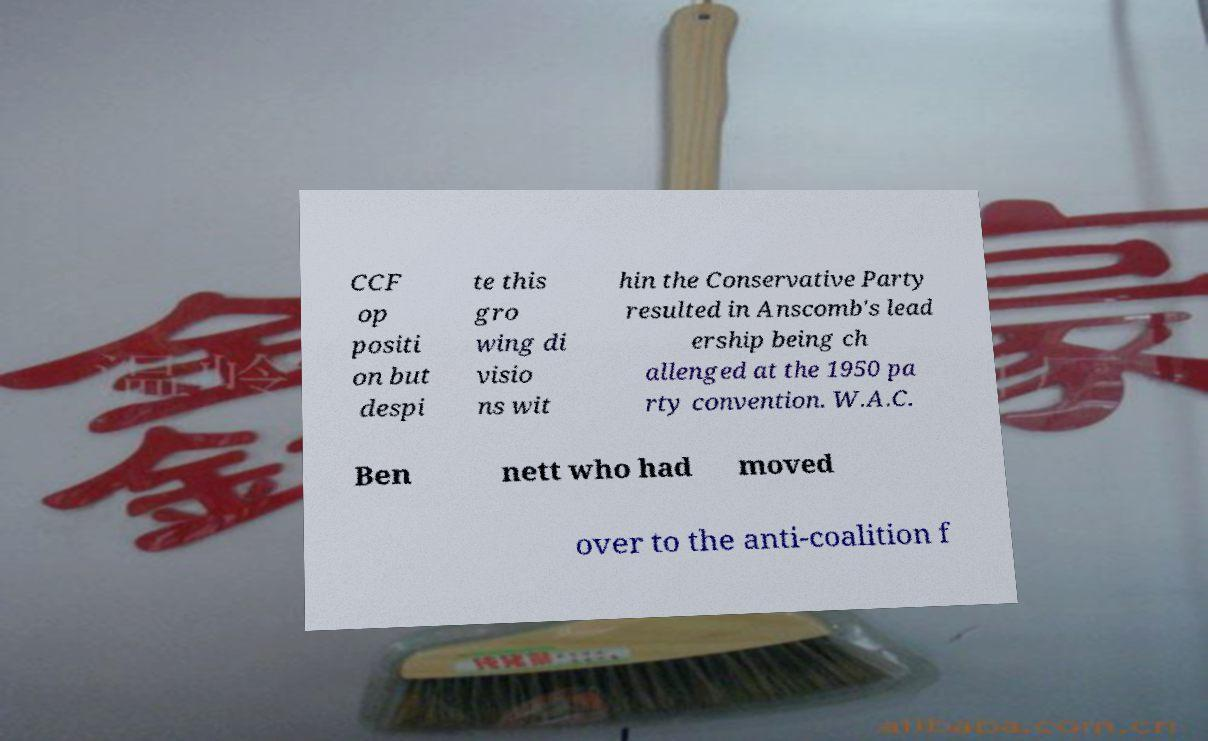Please identify and transcribe the text found in this image. CCF op positi on but despi te this gro wing di visio ns wit hin the Conservative Party resulted in Anscomb's lead ership being ch allenged at the 1950 pa rty convention. W.A.C. Ben nett who had moved over to the anti-coalition f 